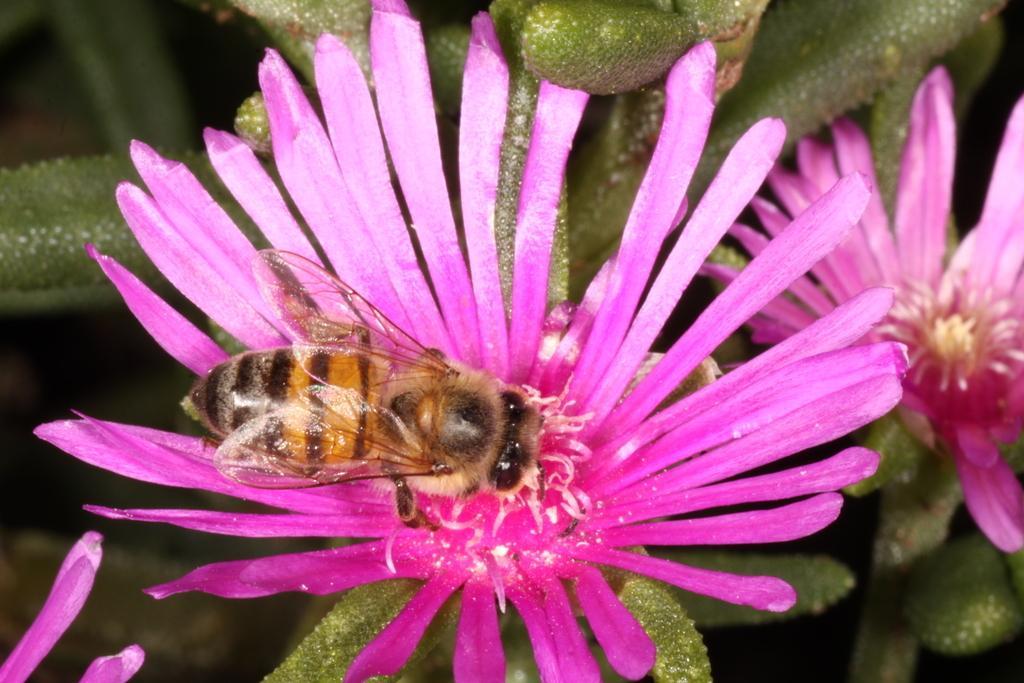Can you describe this image briefly? In this image we can see a flower and leaves of a plant. On the flower there is a honey bee. 